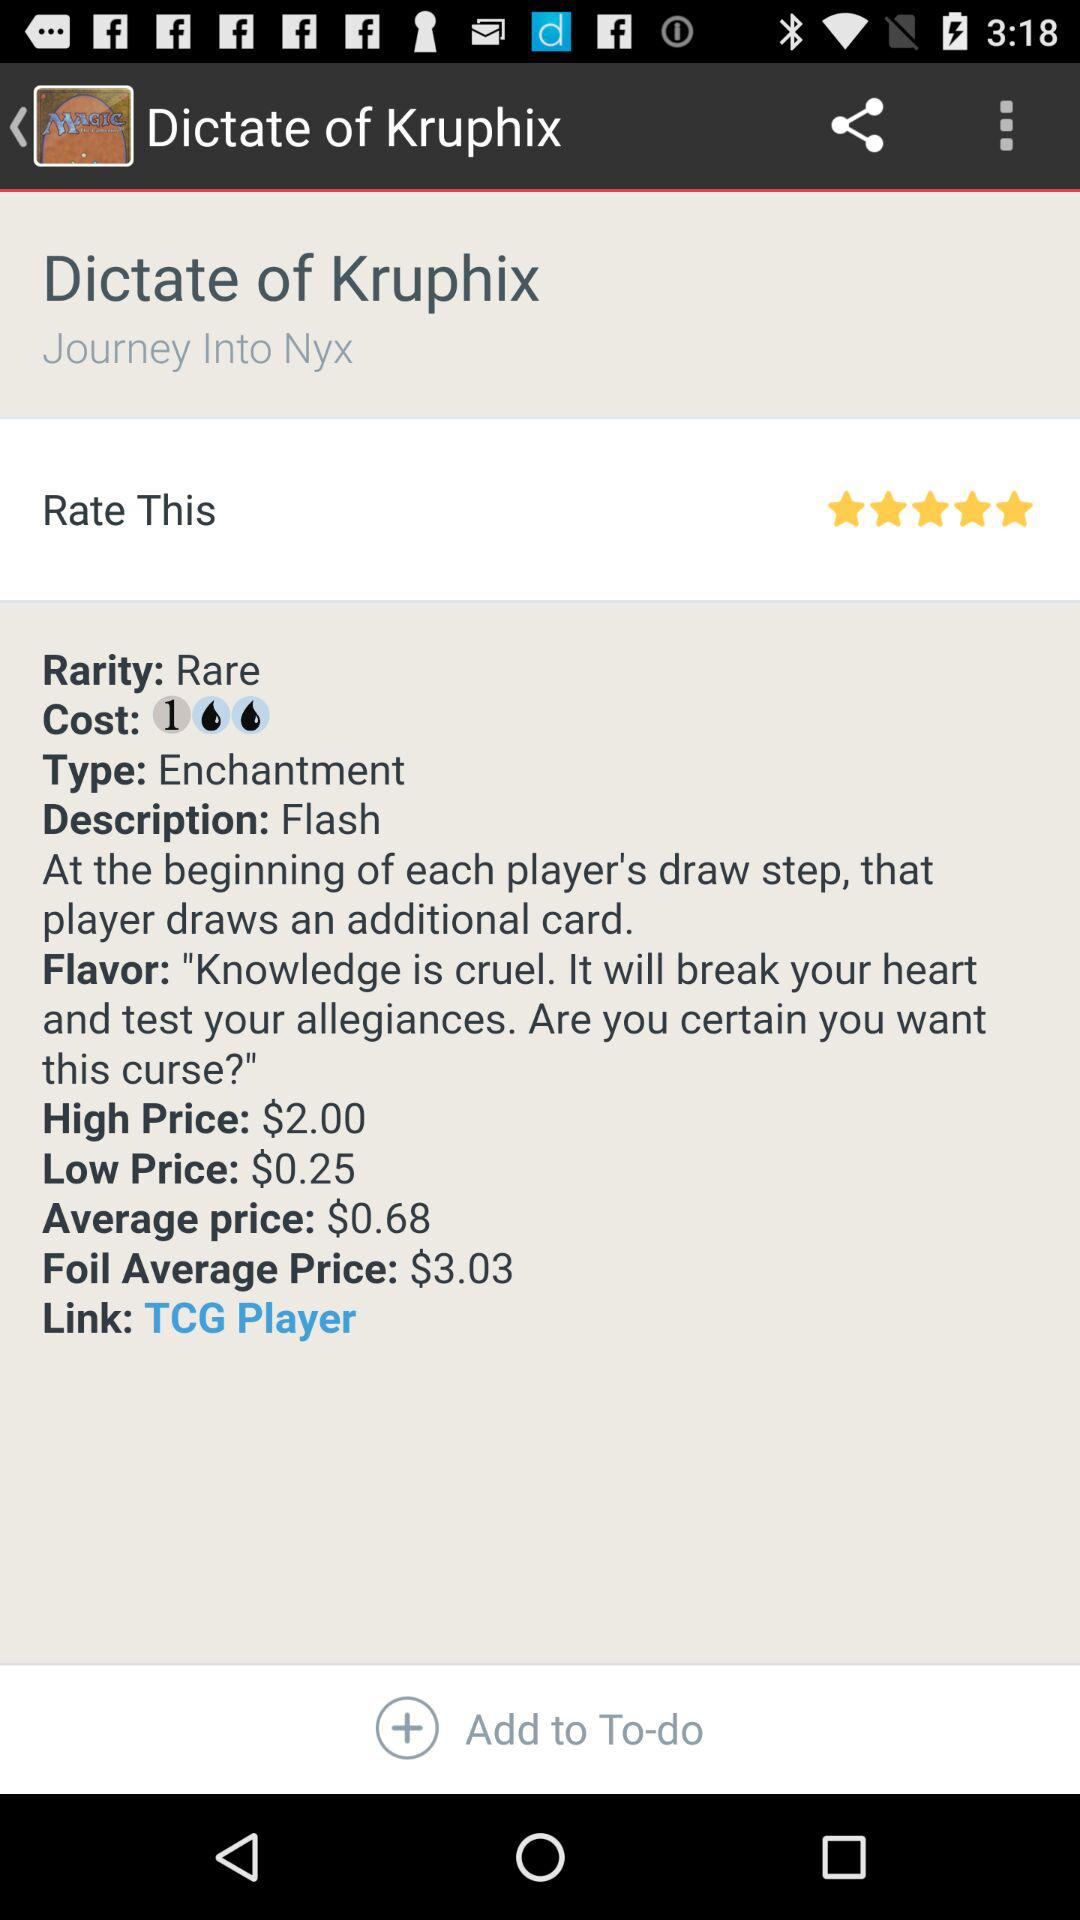What exactly is the rarity? The rarity is "Rare". 